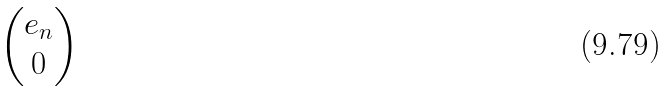<formula> <loc_0><loc_0><loc_500><loc_500>\begin{pmatrix} e _ { n } \\ 0 \end{pmatrix}</formula> 